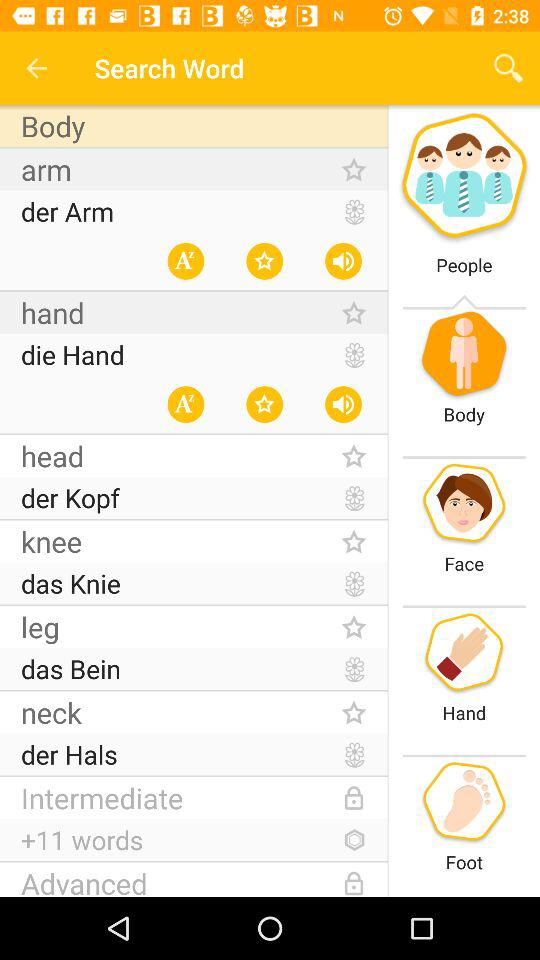Which word has all three options highlighted?
When the provided information is insufficient, respond with <no answer>. <no answer> 